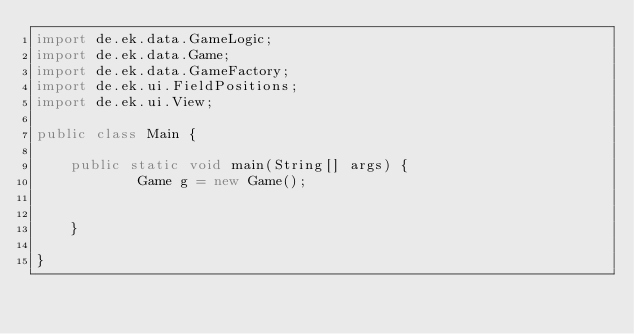<code> <loc_0><loc_0><loc_500><loc_500><_Java_>import de.ek.data.GameLogic;
import de.ek.data.Game;
import de.ek.data.GameFactory;
import de.ek.ui.FieldPositions;
import de.ek.ui.View;

public class Main {

	public static void main(String[] args) {
			Game g = new Game();
			
		
	}

}
</code> 